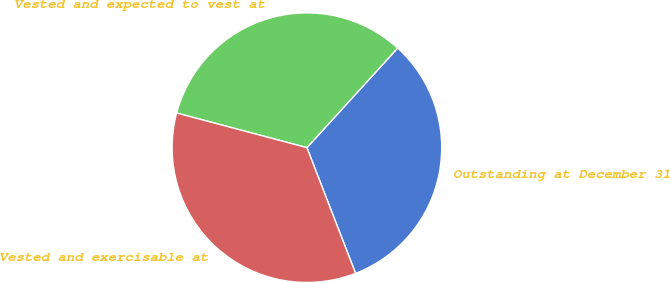<chart> <loc_0><loc_0><loc_500><loc_500><pie_chart><fcel>Outstanding at December 31<fcel>Vested and expected to vest at<fcel>Vested and exercisable at<nl><fcel>32.36%<fcel>32.62%<fcel>35.02%<nl></chart> 